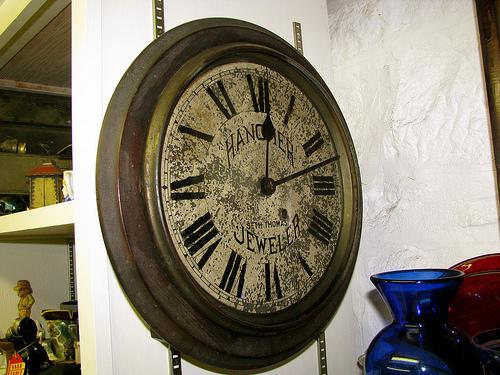Question: what color is the wall in this picture?
Choices:
A. White.
B. Red.
C. Black.
D. Green.
Answer with the letter. Answer: A Question: when was this picture taken?
Choices:
A. 08:36.
B. 11:11.
C. 12:12.
D. 12:59.
Answer with the letter. Answer: C Question: what colors are the vases on the right?
Choices:
A. Light green.
B. Yellow.
C. Orange.
D. Red and blue.
Answer with the letter. Answer: D Question: how many people are pictured here?
Choices:
A. 0.
B. 2.
C. 3.
D. 4.
Answer with the letter. Answer: A Question: how many vases are pictured to the right of the clock?
Choices:
A. 5.
B. 6.
C. 7.
D. 2.
Answer with the letter. Answer: D 